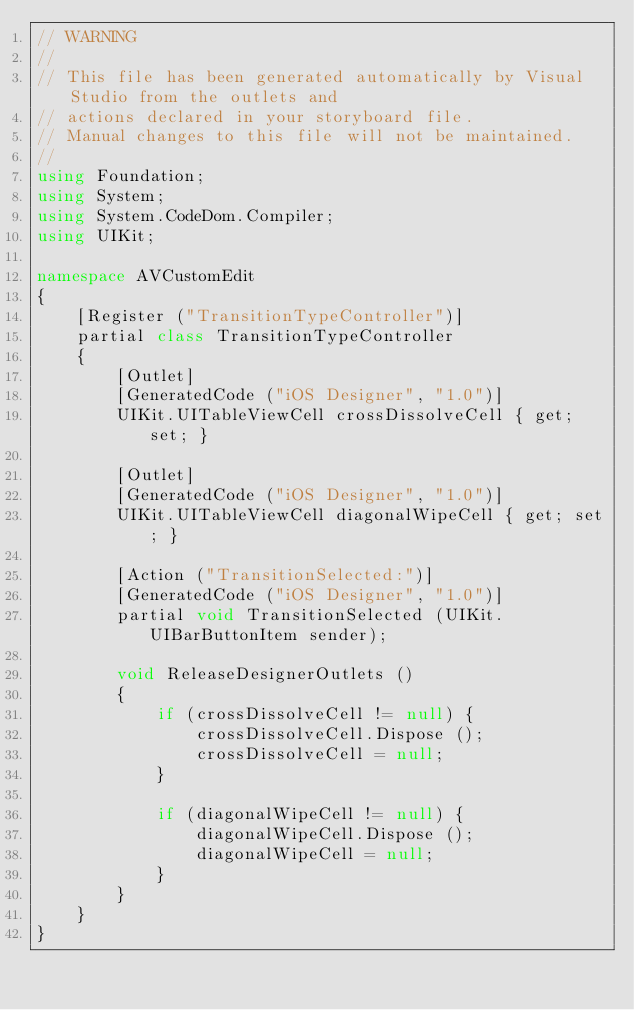Convert code to text. <code><loc_0><loc_0><loc_500><loc_500><_C#_>// WARNING
//
// This file has been generated automatically by Visual Studio from the outlets and
// actions declared in your storyboard file.
// Manual changes to this file will not be maintained.
//
using Foundation;
using System;
using System.CodeDom.Compiler;
using UIKit;

namespace AVCustomEdit
{
    [Register ("TransitionTypeController")]
    partial class TransitionTypeController
    {
        [Outlet]
        [GeneratedCode ("iOS Designer", "1.0")]
        UIKit.UITableViewCell crossDissolveCell { get; set; }

        [Outlet]
        [GeneratedCode ("iOS Designer", "1.0")]
        UIKit.UITableViewCell diagonalWipeCell { get; set; }

        [Action ("TransitionSelected:")]
        [GeneratedCode ("iOS Designer", "1.0")]
        partial void TransitionSelected (UIKit.UIBarButtonItem sender);

        void ReleaseDesignerOutlets ()
        {
            if (crossDissolveCell != null) {
                crossDissolveCell.Dispose ();
                crossDissolveCell = null;
            }

            if (diagonalWipeCell != null) {
                diagonalWipeCell.Dispose ();
                diagonalWipeCell = null;
            }
        }
    }
}</code> 